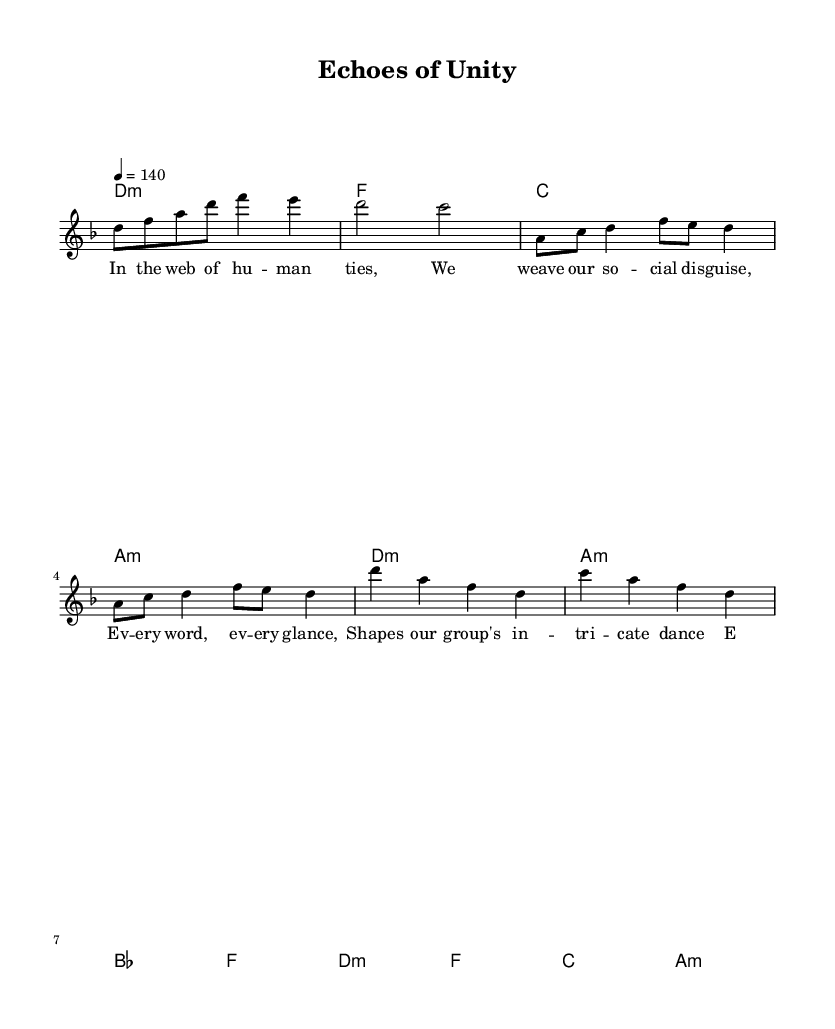What is the key signature of this music? The key signature is D minor, which indicates one flat (B flat). This is identified by looking at the key signature notation at the beginning of the piece.
Answer: D minor What is the time signature of the piece? The time signature is 4/4, indicating there are four beats per measure. This is found at the beginning of the score, indicating the rhythm structure.
Answer: 4/4 What is the tempo marking for the music? The tempo marking is 140 beats per minute. This is located at the beginning of the score next to the tempo indication, which sets the speed for the music.
Answer: 140 How many measures are in the verse section? There are 4 measures in the verse section. This can be counted in the melody line where the verse lyrics are placed beneath.
Answer: 4 What type of chords are primarily featured in the intro? The primary chords featured in the intro are minor chords. This can be observed in the chord names listed, particularly the D minor and A minor chords.
Answer: minor chords What do the lyrics in the verse reflect about social dynamics? The lyrics reflect the concept of interrelationship and communication in social dynamics. Analyzing the text shows themes of human connection, social façades, and group behavior.
Answer: interrelationship What musical elements signify the symphonic nature within the metal genre in this piece? The inclusion of orchestral harmonies and layered melodies signify the symphonic nature of the music. This is identifiable by examining the chord structures combined with the vocal melody in a classical context.
Answer: orchestral harmonies 